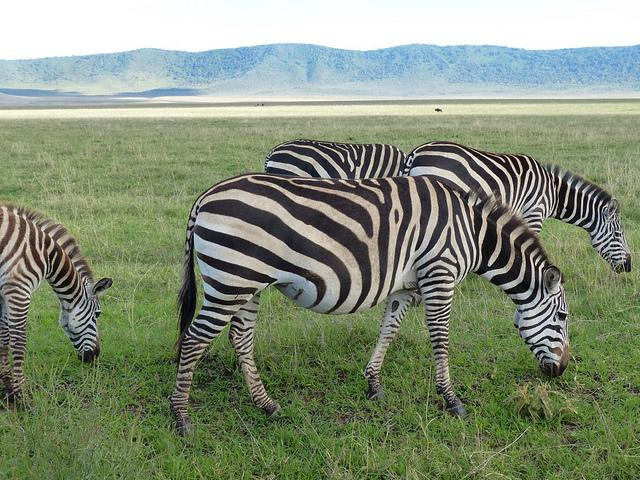What are the zebras doing? Please explain your reasoning. grazing. The zebras are bent with their muzzles to the grass which is consistent with how they eat and with answer a. 